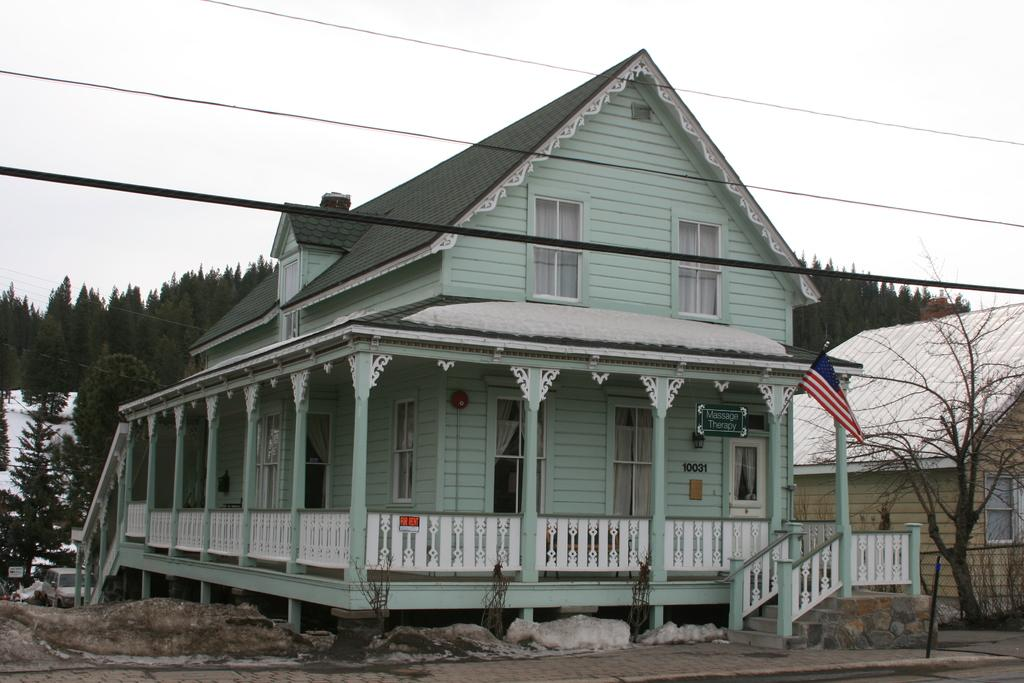What type of structures can be seen in the image? There are houses, a building, and roofs visible in the image. What architectural features are present in the houses? The houses have windows, doors, and curtains. What additional object can be seen in the image? There is a flag and a board present in the image. What can be seen in the background of the image? There are trees, vehicles, electric wires, and sky visible in the background of the image. What is the tendency of the account in the image? There is no account present in the image, as it features houses, a building, and other structures. What type of camp can be seen in the image? There is no camp present in the image; it features houses, a building, and other structures. 